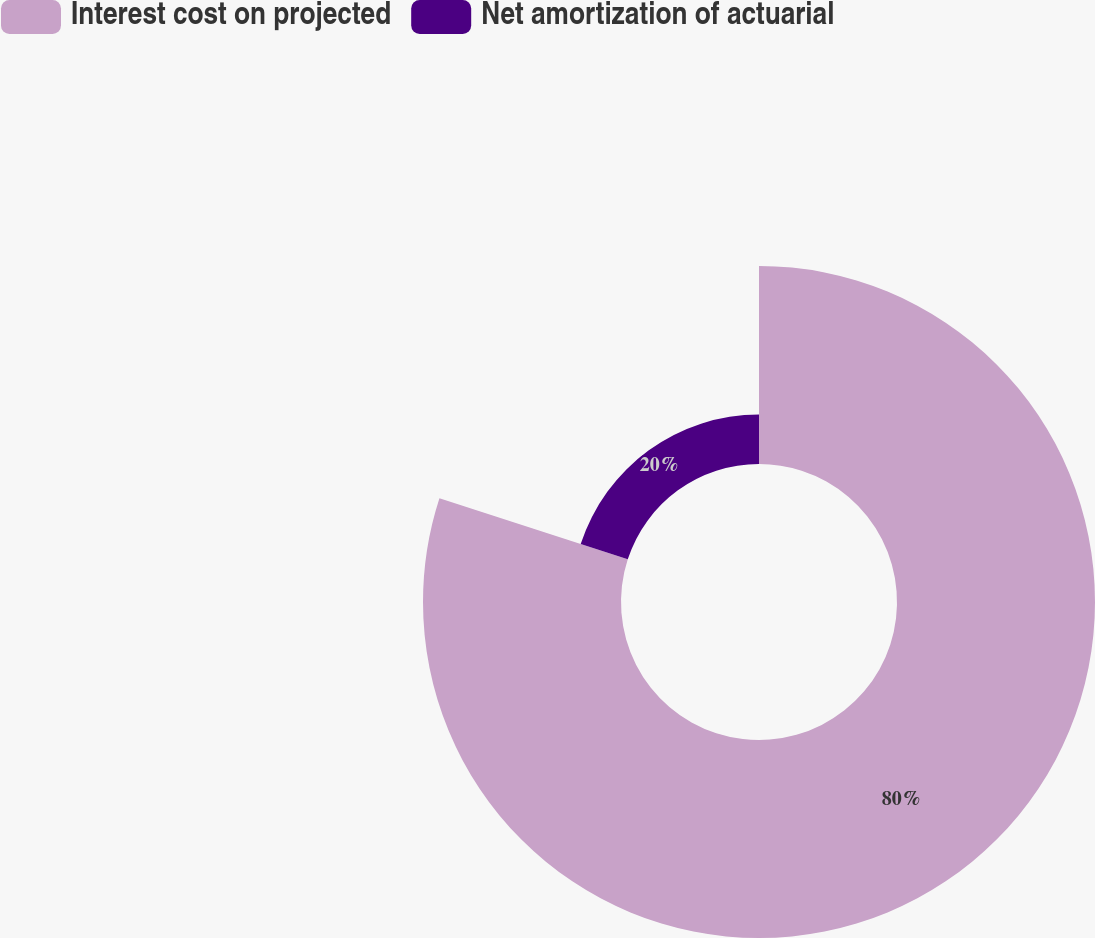Convert chart to OTSL. <chart><loc_0><loc_0><loc_500><loc_500><pie_chart><fcel>Interest cost on projected<fcel>Net amortization of actuarial<nl><fcel>80.0%<fcel>20.0%<nl></chart> 